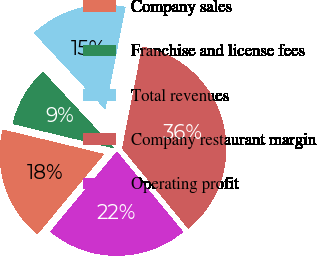<chart> <loc_0><loc_0><loc_500><loc_500><pie_chart><fcel>Company sales<fcel>Franchise and license fees<fcel>Total revenues<fcel>Company restaurant margin<fcel>Operating profit<nl><fcel>17.73%<fcel>9.27%<fcel>15.06%<fcel>35.92%<fcel>22.02%<nl></chart> 